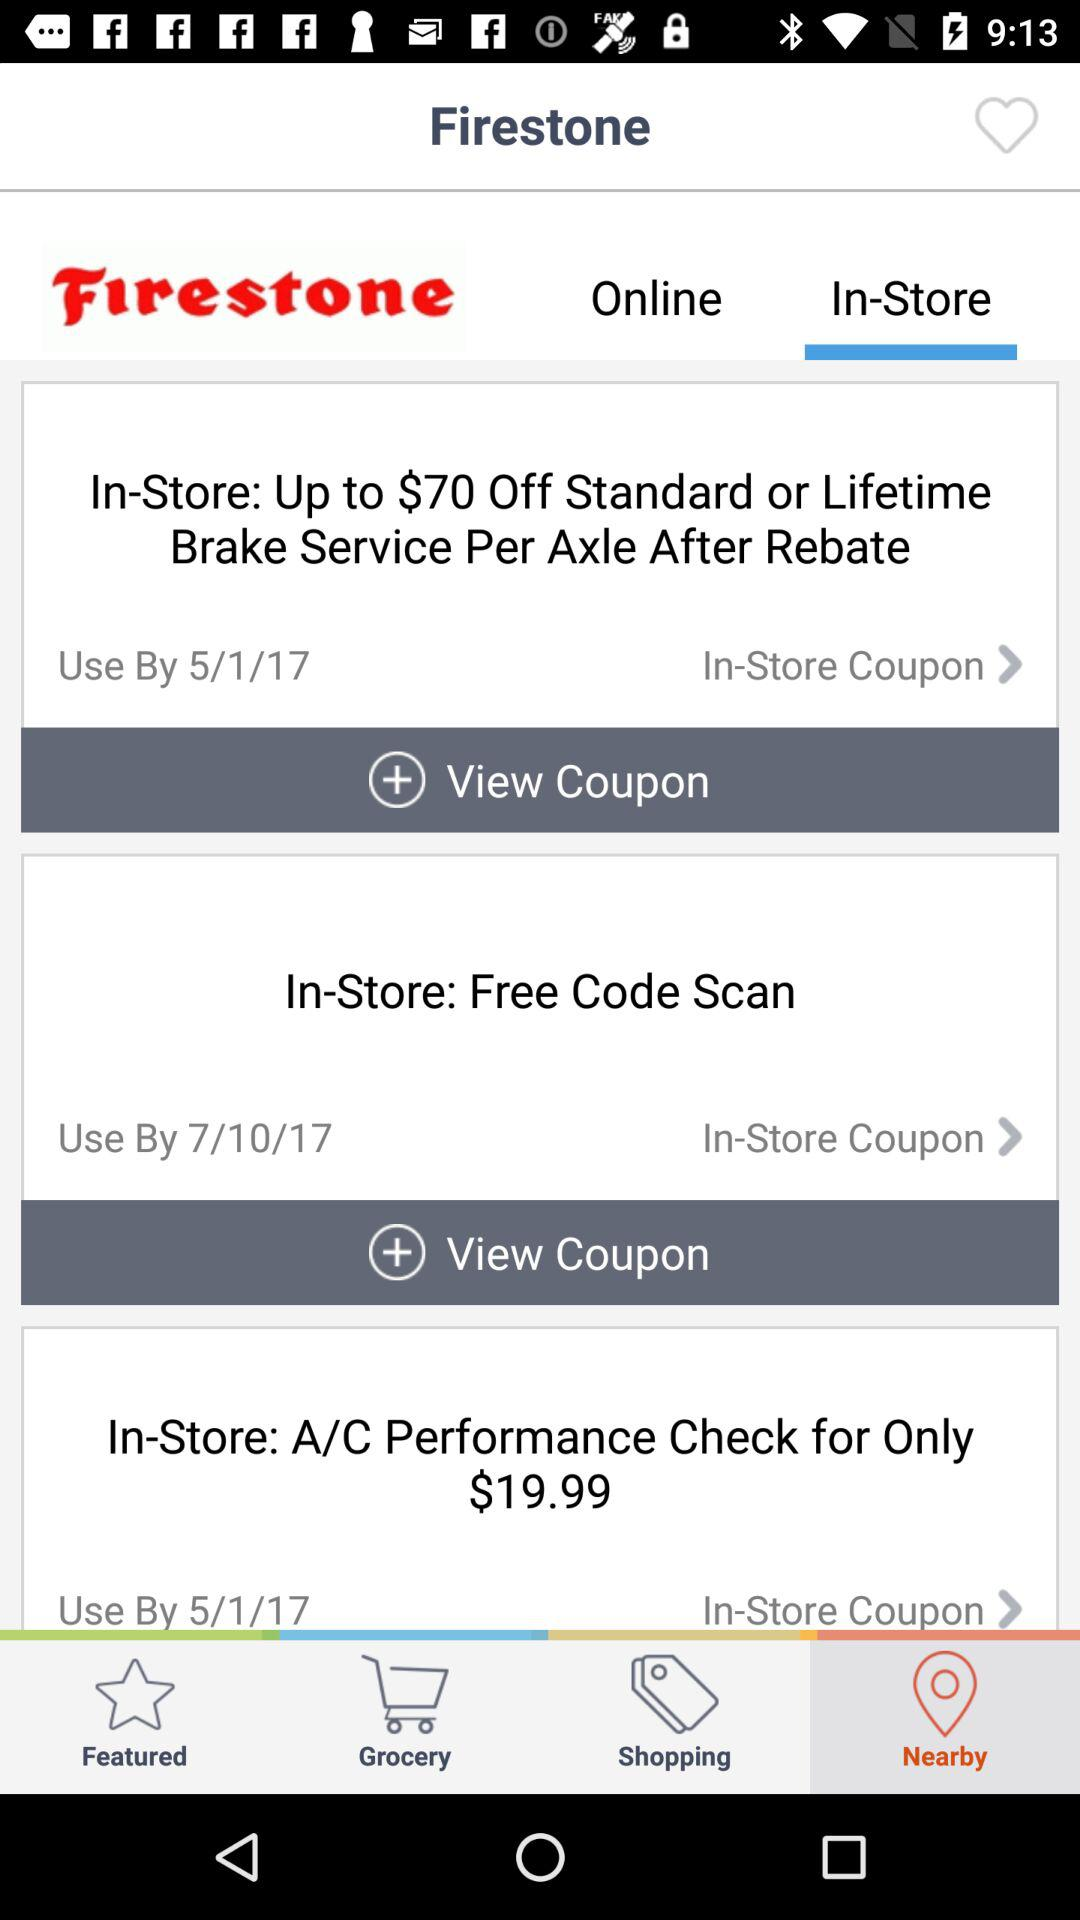How many coupons are there?
Answer the question using a single word or phrase. 3 